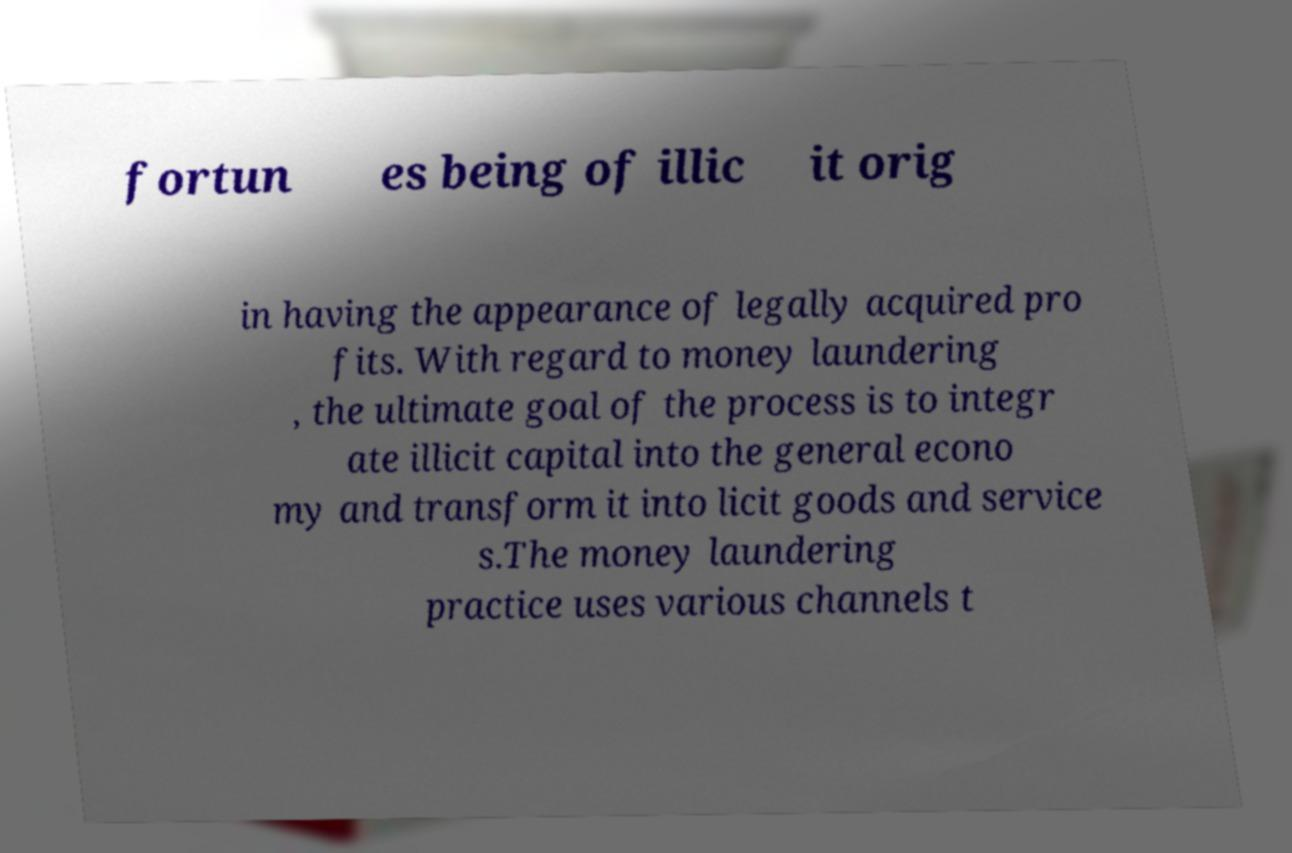Please read and relay the text visible in this image. What does it say? fortun es being of illic it orig in having the appearance of legally acquired pro fits. With regard to money laundering , the ultimate goal of the process is to integr ate illicit capital into the general econo my and transform it into licit goods and service s.The money laundering practice uses various channels t 